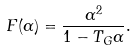Convert formula to latex. <formula><loc_0><loc_0><loc_500><loc_500>F ( \alpha ) = \frac { \alpha ^ { 2 } } { 1 - T _ { G } \alpha } .</formula> 